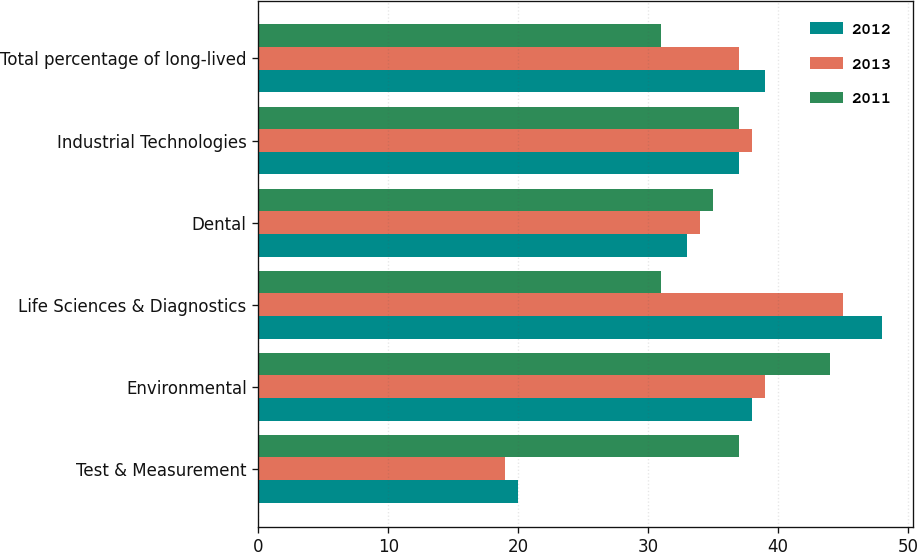<chart> <loc_0><loc_0><loc_500><loc_500><stacked_bar_chart><ecel><fcel>Test & Measurement<fcel>Environmental<fcel>Life Sciences & Diagnostics<fcel>Dental<fcel>Industrial Technologies<fcel>Total percentage of long-lived<nl><fcel>2012<fcel>20<fcel>38<fcel>48<fcel>33<fcel>37<fcel>39<nl><fcel>2013<fcel>19<fcel>39<fcel>45<fcel>34<fcel>38<fcel>37<nl><fcel>2011<fcel>37<fcel>44<fcel>31<fcel>35<fcel>37<fcel>31<nl></chart> 